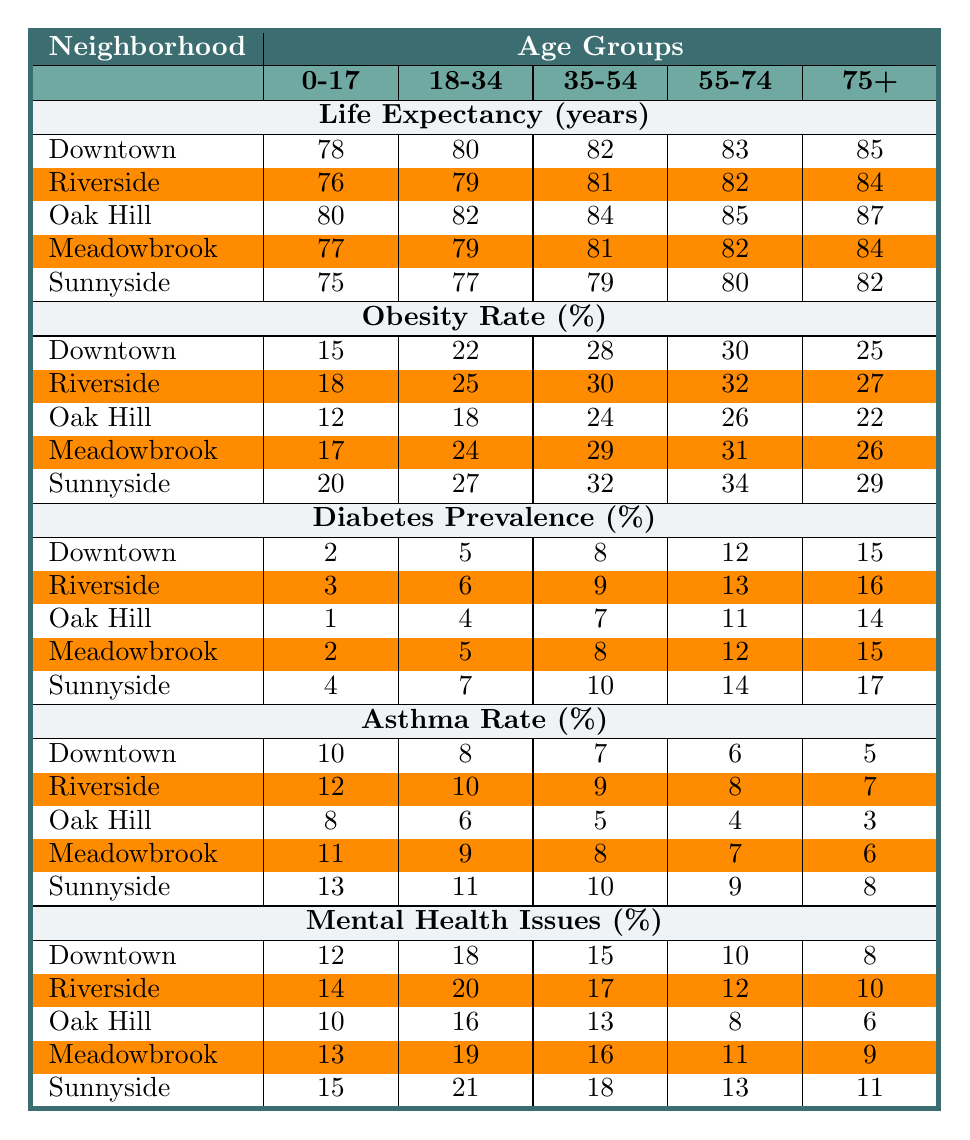What is the life expectancy for the 0-17 age group in Oak Hill? The table shows that for the life expectancy metric in Oak Hill, the value corresponding to the 0-17 age group is 80 years.
Answer: 80 Which neighborhood has the highest obesity rate for the 75+ age group? Looking at the obesity rate percentages for the 75+ age group, Sunnyside has the highest value at 29%.
Answer: Sunnyside What is the average diabetes prevalence for the 18-34 age group across all neighborhoods? The diabetes prevalence percentages for the 18-34 age group are: Downtown (5), Riverside (6), Oak Hill (4), Meadowbrook (5), and Sunnyside (7). The total is 5 + 6 + 4 + 5 + 7 = 27. There are 5 neighborhoods, so the average is 27 / 5 = 5.4%.
Answer: 5.4% Does Riversides have a higher mental health issue percentage for the 35-54 age group compared to Meadowbrook? Riverside's mental health issues percentage for the 35-54 age group is 17%, while Meadowbrook's is 16%. Since 17% is greater than 16%, the statement is true.
Answer: Yes What is the trend of asthma rates for the 55-74 age group across the neighborhoods? The asthma rates for the 55-74 age group are as follows: Downtown (6%), Riverside (8%), Oak Hill (4%), Meadowbrook (7%), and Sunnyside (9%). The trend shows an increase from Downtown to Sunnyside except for a drop in Oak Hill. Thus, generally, it's an upward trend with a dip at Oak Hill.
Answer: Generally increasing Which neighborhood has the lowest life expectancy for the 55-74 age group? For the 55-74 age group, the life expectancy values are: Downtown (83), Riverside (82), Oak Hill (85), Meadowbrook (82), and Sunnyside (80). The lowest value is in Sunnyside at 80 years.
Answer: Sunnyside What is the difference in obesity rates between the 18-34 age group in Downtown and Oak Hill? The obesity rates for the 18-34 age group are 22% for Downtown and 18% for Oak Hill. The difference is calculated as 22% - 18% = 4%.
Answer: 4% Is the asthma rate for the 0-17 age group lower in Oak Hill than in Riverside? The asthma rate for the 0-17 age group is 8% in Oak Hill and 12% in Riverside. Since 8% is less than 12%, the statement is true.
Answer: Yes What is the average life expectancy in Downtown and Sunnyside for the 75+ age group? In Downtown, the life expectancy for the 75+ age group is 85 years, and in Sunnyside, it is 82 years. The sum is 85 + 82 = 167. The average is 167 / 2 = 83.5 years.
Answer: 83.5 For which age group does Oak Hill show the lowest diabetes prevalence? The diabetes prevalence percentages in Oak Hill are: 1% for 0-17, 4% for 18-34, 7% for 35-54, 11% for 55-74, and 14% for 75+. The lowest percentage is 1% for the 0-17 age group.
Answer: 0-17 age group Are mental health issues more prevalent in Downtown compared to Riverside for the 55-74 age group? Downtown has a mental health issue percentage of 10% for the 55-74 age group, while Riverside has 12%. Thus, Downtown has a lower percentage than Riverside. The statement is false.
Answer: No 